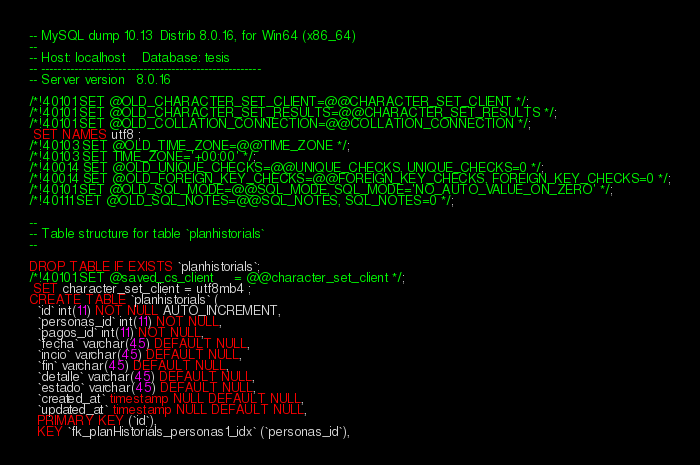Convert code to text. <code><loc_0><loc_0><loc_500><loc_500><_SQL_>-- MySQL dump 10.13  Distrib 8.0.16, for Win64 (x86_64)
--
-- Host: localhost    Database: tesis
-- ------------------------------------------------------
-- Server version	8.0.16

/*!40101 SET @OLD_CHARACTER_SET_CLIENT=@@CHARACTER_SET_CLIENT */;
/*!40101 SET @OLD_CHARACTER_SET_RESULTS=@@CHARACTER_SET_RESULTS */;
/*!40101 SET @OLD_COLLATION_CONNECTION=@@COLLATION_CONNECTION */;
 SET NAMES utf8 ;
/*!40103 SET @OLD_TIME_ZONE=@@TIME_ZONE */;
/*!40103 SET TIME_ZONE='+00:00' */;
/*!40014 SET @OLD_UNIQUE_CHECKS=@@UNIQUE_CHECKS, UNIQUE_CHECKS=0 */;
/*!40014 SET @OLD_FOREIGN_KEY_CHECKS=@@FOREIGN_KEY_CHECKS, FOREIGN_KEY_CHECKS=0 */;
/*!40101 SET @OLD_SQL_MODE=@@SQL_MODE, SQL_MODE='NO_AUTO_VALUE_ON_ZERO' */;
/*!40111 SET @OLD_SQL_NOTES=@@SQL_NOTES, SQL_NOTES=0 */;

--
-- Table structure for table `planhistorials`
--

DROP TABLE IF EXISTS `planhistorials`;
/*!40101 SET @saved_cs_client     = @@character_set_client */;
 SET character_set_client = utf8mb4 ;
CREATE TABLE `planhistorials` (
  `id` int(11) NOT NULL AUTO_INCREMENT,
  `personas_id` int(11) NOT NULL,
  `pagos_id` int(11) NOT NULL,
  `fecha` varchar(45) DEFAULT NULL,
  `incio` varchar(45) DEFAULT NULL,
  `fin` varchar(45) DEFAULT NULL,
  `detalle` varchar(45) DEFAULT NULL,
  `estado` varchar(45) DEFAULT NULL,
  `created_at` timestamp NULL DEFAULT NULL,
  `updated_at` timestamp NULL DEFAULT NULL,
  PRIMARY KEY (`id`),
  KEY `fk_planHistorials_personas1_idx` (`personas_id`),</code> 